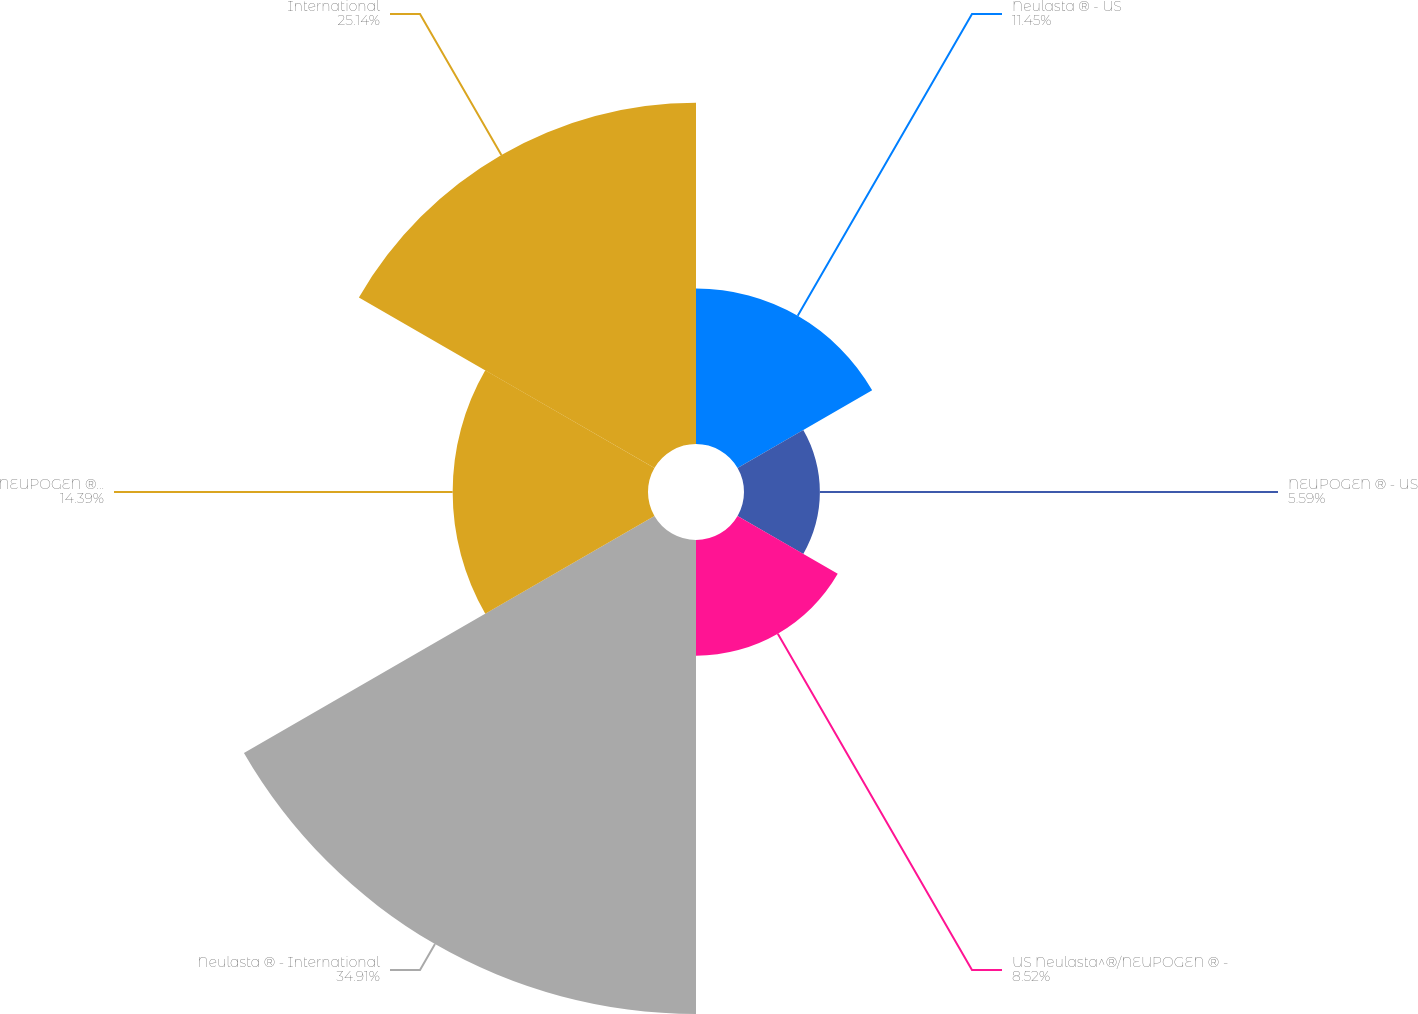Convert chart. <chart><loc_0><loc_0><loc_500><loc_500><pie_chart><fcel>Neulasta ® - US<fcel>NEUPOGEN ® - US<fcel>US Neulasta^®/NEUPOGEN ® -<fcel>Neulasta ® - International<fcel>NEUPOGEN ® - International<fcel>International<nl><fcel>11.45%<fcel>5.59%<fcel>8.52%<fcel>34.92%<fcel>14.39%<fcel>25.14%<nl></chart> 